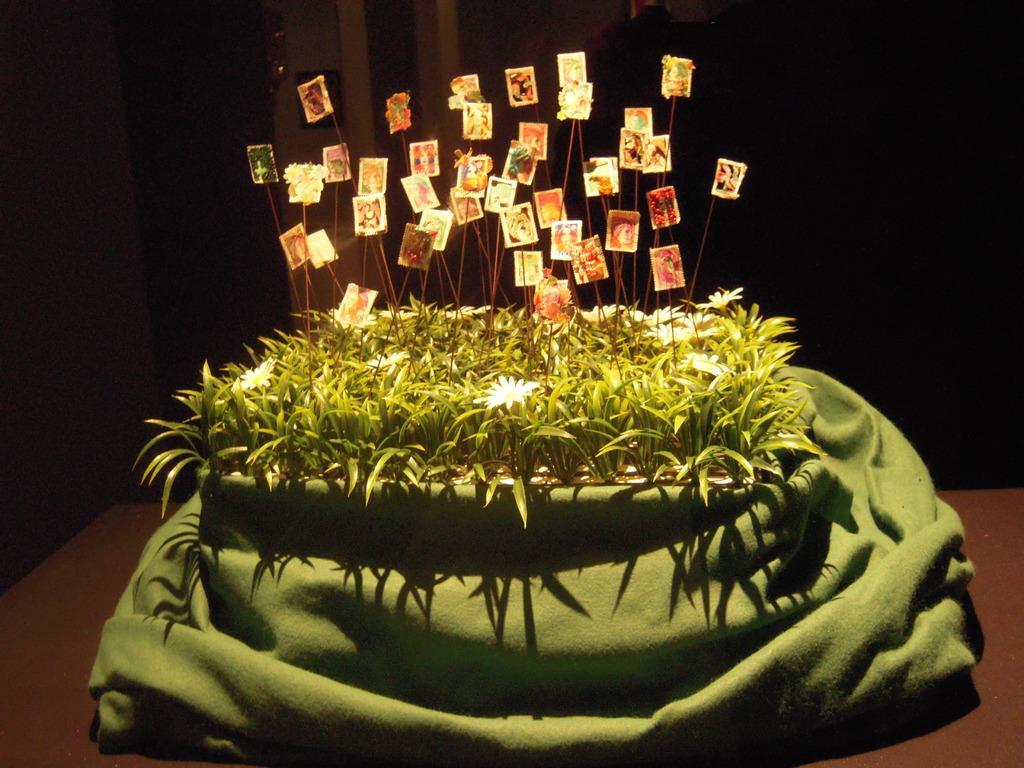Can you describe this image briefly? In this image, we can see stickers attached to sticks and are placed in the flower pot and we can see a bag. At the bottom, there is table and in the background, there is wall and some of it is dark. 